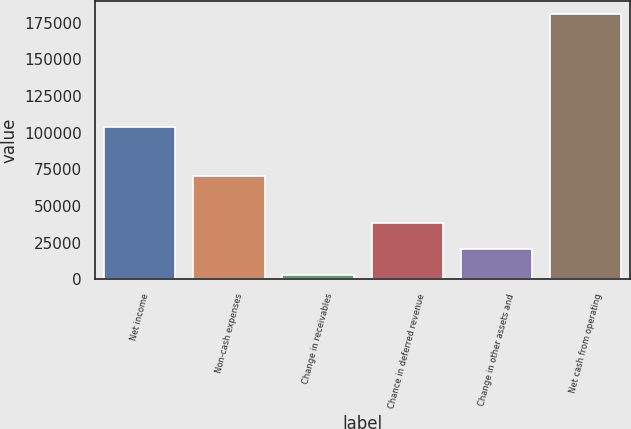Convert chart. <chart><loc_0><loc_0><loc_500><loc_500><bar_chart><fcel>Net income<fcel>Non-cash expenses<fcel>Change in receivables<fcel>Chance in deferred revenue<fcel>Change in other assets and<fcel>Net cash from operating<nl><fcel>104222<fcel>70420<fcel>2913<fcel>38530.6<fcel>20721.8<fcel>181001<nl></chart> 